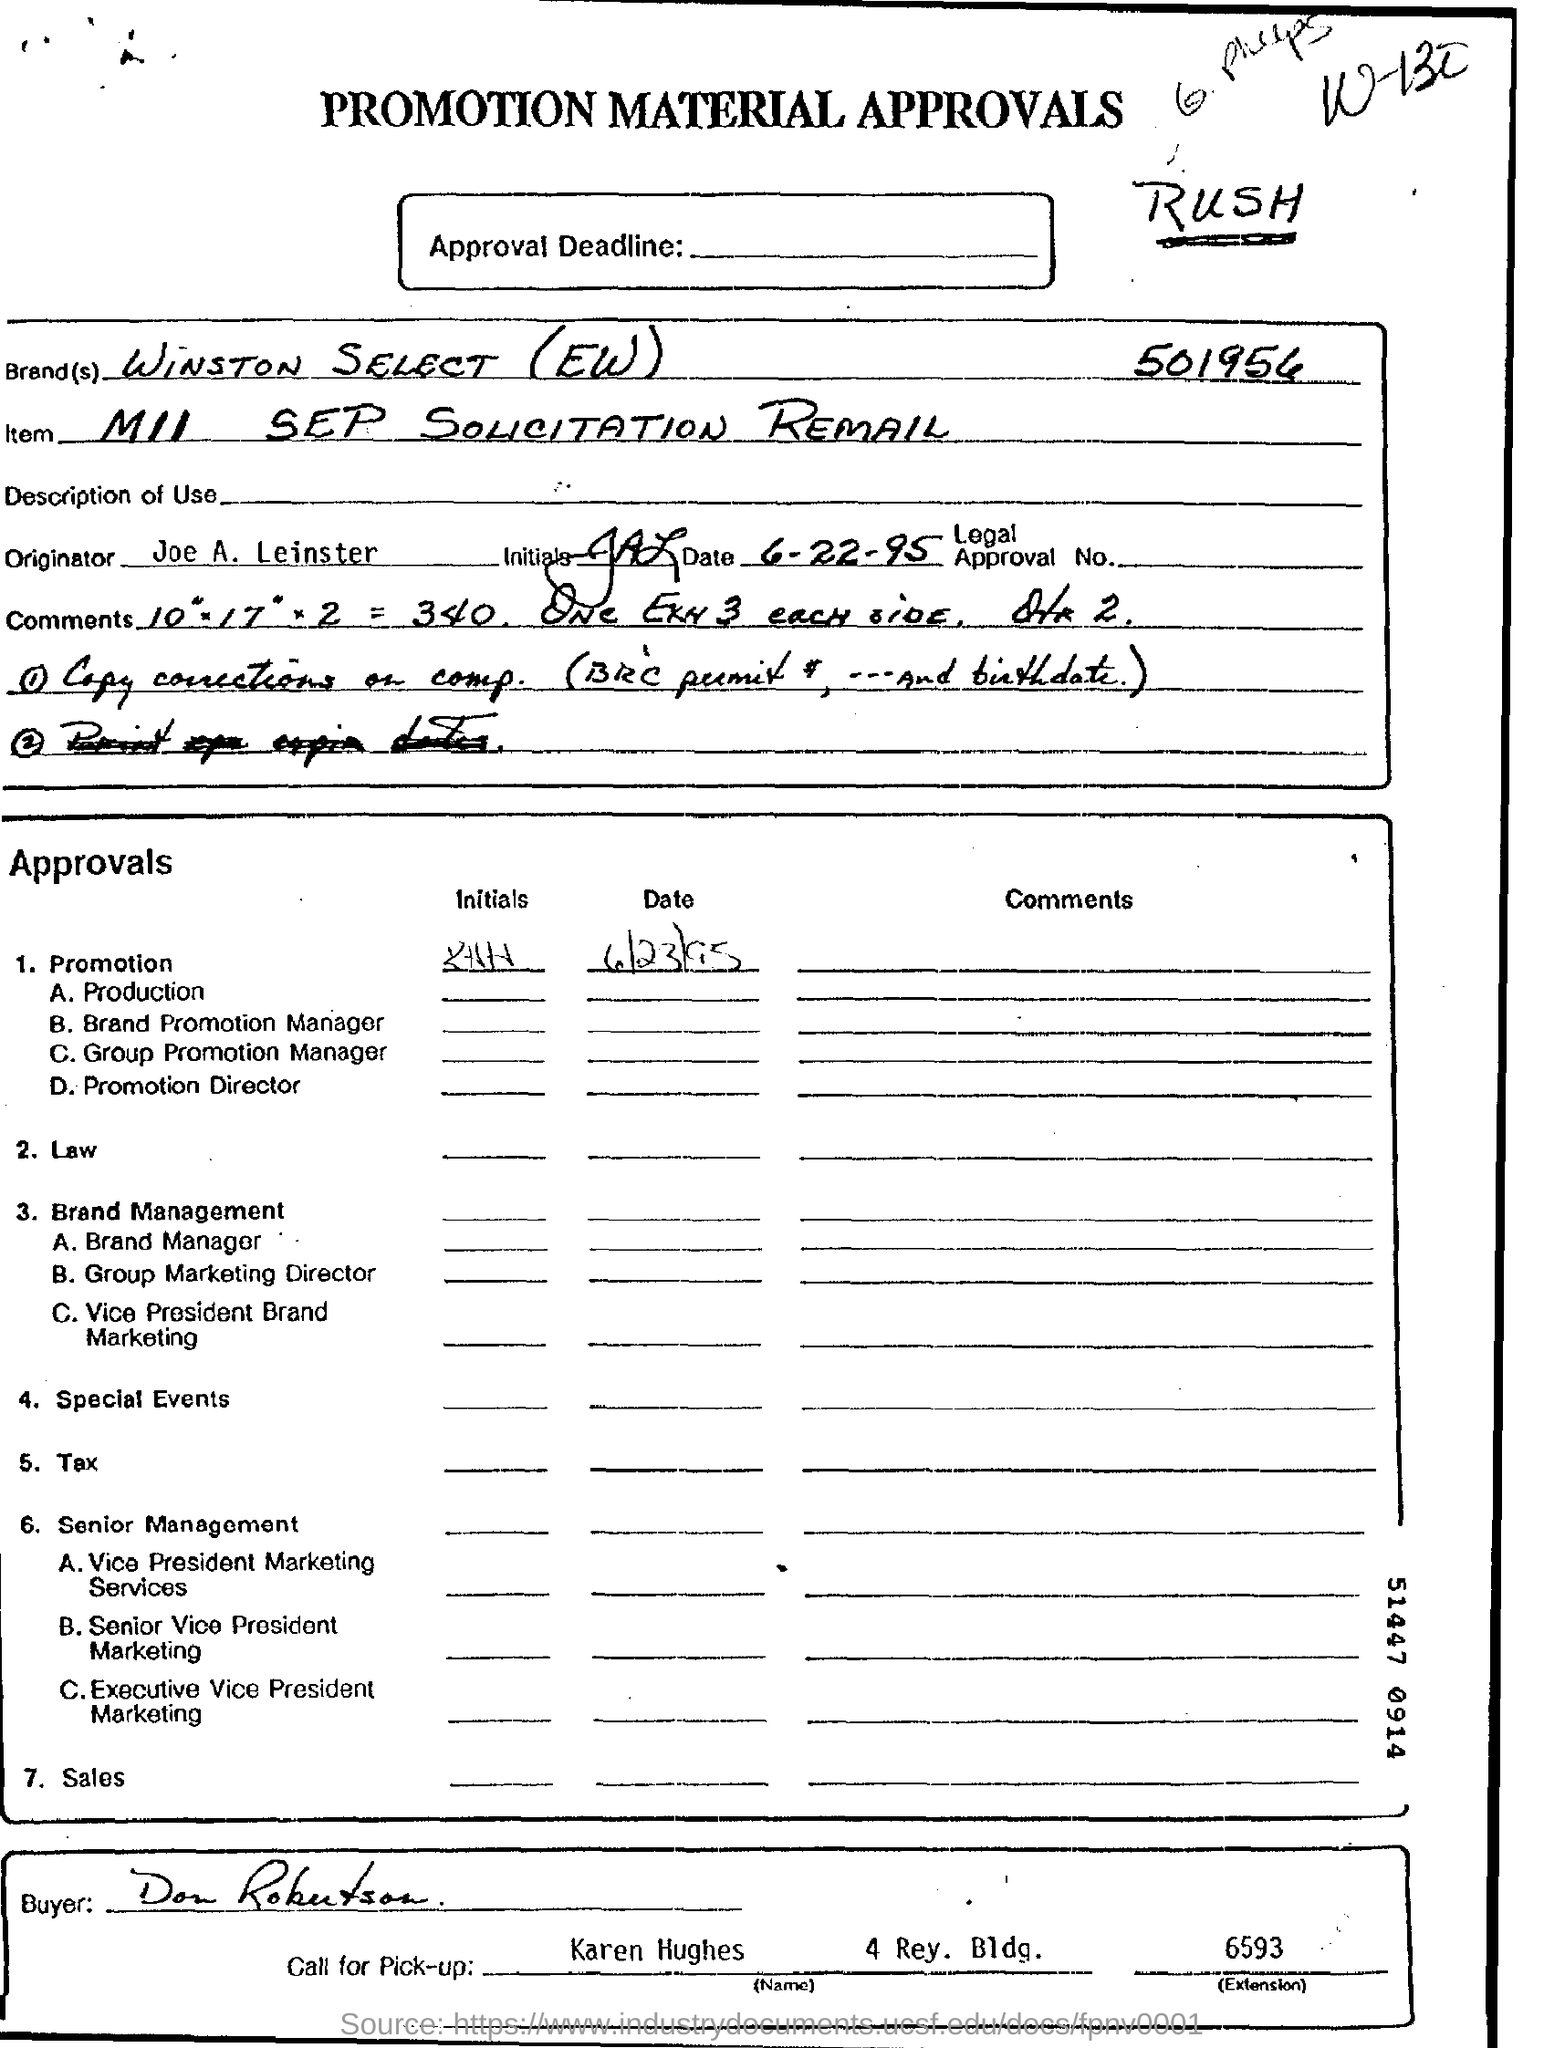Highlight a few significant elements in this photo. The buyer's name is Don Robutson. The item is known as "MII SEP SOLICITATION REMAIL. The name of the originator is Joe A. Leinster. The brand is called Winston Select (EW). 